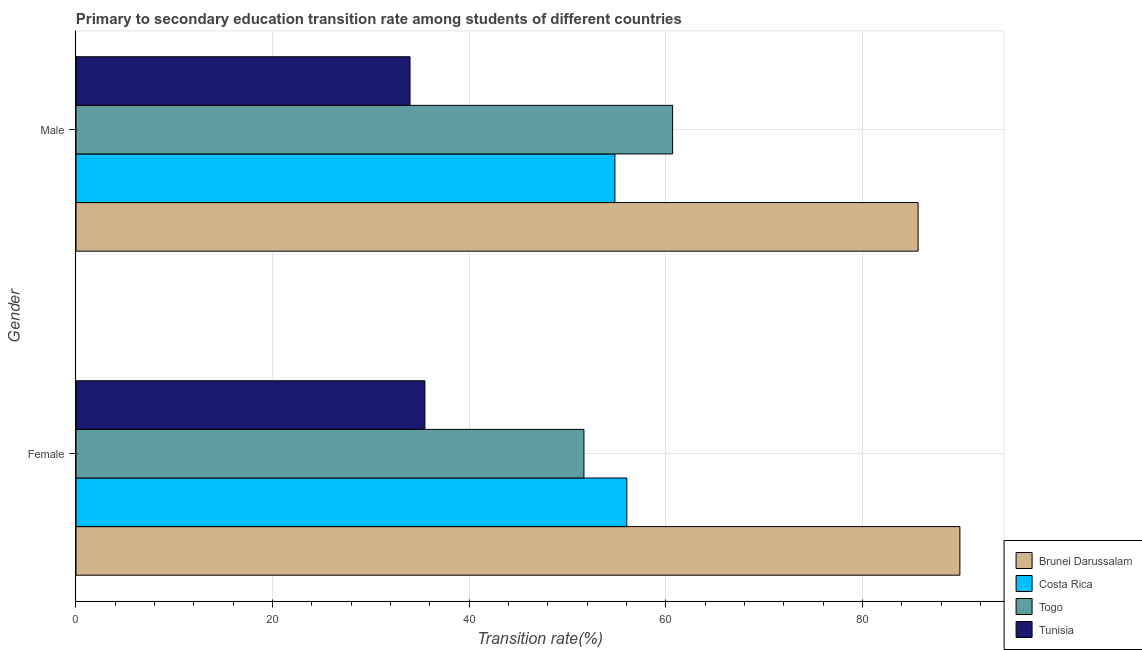What is the label of the 1st group of bars from the top?
Ensure brevity in your answer.  Male. What is the transition rate among female students in Tunisia?
Provide a succinct answer. 35.49. Across all countries, what is the maximum transition rate among male students?
Provide a short and direct response. 85.65. Across all countries, what is the minimum transition rate among male students?
Keep it short and to the point. 33.98. In which country was the transition rate among male students maximum?
Provide a succinct answer. Brunei Darussalam. In which country was the transition rate among male students minimum?
Keep it short and to the point. Tunisia. What is the total transition rate among female students in the graph?
Offer a terse response. 233.09. What is the difference between the transition rate among male students in Togo and that in Brunei Darussalam?
Offer a terse response. -24.97. What is the difference between the transition rate among female students in Tunisia and the transition rate among male students in Costa Rica?
Keep it short and to the point. -19.32. What is the average transition rate among male students per country?
Give a very brief answer. 58.78. What is the difference between the transition rate among male students and transition rate among female students in Costa Rica?
Your answer should be very brief. -1.21. In how many countries, is the transition rate among female students greater than 24 %?
Your answer should be very brief. 4. What is the ratio of the transition rate among female students in Togo to that in Tunisia?
Ensure brevity in your answer.  1.46. What does the 2nd bar from the top in Male represents?
Keep it short and to the point. Togo. What does the 3rd bar from the bottom in Female represents?
Keep it short and to the point. Togo. How many bars are there?
Make the answer very short. 8. How many countries are there in the graph?
Your answer should be compact. 4. What is the difference between two consecutive major ticks on the X-axis?
Provide a short and direct response. 20. Does the graph contain any zero values?
Make the answer very short. No. Does the graph contain grids?
Make the answer very short. Yes. How many legend labels are there?
Provide a short and direct response. 4. How are the legend labels stacked?
Give a very brief answer. Vertical. What is the title of the graph?
Your answer should be compact. Primary to secondary education transition rate among students of different countries. Does "Fiji" appear as one of the legend labels in the graph?
Your response must be concise. No. What is the label or title of the X-axis?
Make the answer very short. Transition rate(%). What is the Transition rate(%) of Brunei Darussalam in Female?
Ensure brevity in your answer.  89.9. What is the Transition rate(%) in Costa Rica in Female?
Offer a terse response. 56.03. What is the Transition rate(%) in Togo in Female?
Offer a terse response. 51.67. What is the Transition rate(%) in Tunisia in Female?
Make the answer very short. 35.49. What is the Transition rate(%) of Brunei Darussalam in Male?
Give a very brief answer. 85.65. What is the Transition rate(%) of Costa Rica in Male?
Your answer should be very brief. 54.82. What is the Transition rate(%) of Togo in Male?
Keep it short and to the point. 60.68. What is the Transition rate(%) of Tunisia in Male?
Your answer should be compact. 33.98. Across all Gender, what is the maximum Transition rate(%) of Brunei Darussalam?
Keep it short and to the point. 89.9. Across all Gender, what is the maximum Transition rate(%) in Costa Rica?
Give a very brief answer. 56.03. Across all Gender, what is the maximum Transition rate(%) of Togo?
Ensure brevity in your answer.  60.68. Across all Gender, what is the maximum Transition rate(%) in Tunisia?
Offer a terse response. 35.49. Across all Gender, what is the minimum Transition rate(%) in Brunei Darussalam?
Your answer should be compact. 85.65. Across all Gender, what is the minimum Transition rate(%) of Costa Rica?
Provide a short and direct response. 54.82. Across all Gender, what is the minimum Transition rate(%) of Togo?
Offer a very short reply. 51.67. Across all Gender, what is the minimum Transition rate(%) of Tunisia?
Give a very brief answer. 33.98. What is the total Transition rate(%) in Brunei Darussalam in the graph?
Offer a very short reply. 175.56. What is the total Transition rate(%) of Costa Rica in the graph?
Ensure brevity in your answer.  110.84. What is the total Transition rate(%) in Togo in the graph?
Give a very brief answer. 112.35. What is the total Transition rate(%) of Tunisia in the graph?
Provide a succinct answer. 69.47. What is the difference between the Transition rate(%) in Brunei Darussalam in Female and that in Male?
Keep it short and to the point. 4.25. What is the difference between the Transition rate(%) of Costa Rica in Female and that in Male?
Provide a short and direct response. 1.21. What is the difference between the Transition rate(%) of Togo in Female and that in Male?
Ensure brevity in your answer.  -9.02. What is the difference between the Transition rate(%) in Tunisia in Female and that in Male?
Ensure brevity in your answer.  1.52. What is the difference between the Transition rate(%) of Brunei Darussalam in Female and the Transition rate(%) of Costa Rica in Male?
Keep it short and to the point. 35.09. What is the difference between the Transition rate(%) in Brunei Darussalam in Female and the Transition rate(%) in Togo in Male?
Ensure brevity in your answer.  29.22. What is the difference between the Transition rate(%) in Brunei Darussalam in Female and the Transition rate(%) in Tunisia in Male?
Offer a terse response. 55.93. What is the difference between the Transition rate(%) of Costa Rica in Female and the Transition rate(%) of Togo in Male?
Provide a short and direct response. -4.66. What is the difference between the Transition rate(%) of Costa Rica in Female and the Transition rate(%) of Tunisia in Male?
Keep it short and to the point. 22.05. What is the difference between the Transition rate(%) in Togo in Female and the Transition rate(%) in Tunisia in Male?
Provide a short and direct response. 17.69. What is the average Transition rate(%) of Brunei Darussalam per Gender?
Your response must be concise. 87.78. What is the average Transition rate(%) in Costa Rica per Gender?
Give a very brief answer. 55.42. What is the average Transition rate(%) in Togo per Gender?
Make the answer very short. 56.17. What is the average Transition rate(%) in Tunisia per Gender?
Keep it short and to the point. 34.73. What is the difference between the Transition rate(%) in Brunei Darussalam and Transition rate(%) in Costa Rica in Female?
Your answer should be compact. 33.88. What is the difference between the Transition rate(%) in Brunei Darussalam and Transition rate(%) in Togo in Female?
Give a very brief answer. 38.24. What is the difference between the Transition rate(%) of Brunei Darussalam and Transition rate(%) of Tunisia in Female?
Offer a terse response. 54.41. What is the difference between the Transition rate(%) in Costa Rica and Transition rate(%) in Togo in Female?
Ensure brevity in your answer.  4.36. What is the difference between the Transition rate(%) of Costa Rica and Transition rate(%) of Tunisia in Female?
Offer a very short reply. 20.54. What is the difference between the Transition rate(%) in Togo and Transition rate(%) in Tunisia in Female?
Offer a terse response. 16.17. What is the difference between the Transition rate(%) of Brunei Darussalam and Transition rate(%) of Costa Rica in Male?
Provide a succinct answer. 30.84. What is the difference between the Transition rate(%) in Brunei Darussalam and Transition rate(%) in Togo in Male?
Ensure brevity in your answer.  24.97. What is the difference between the Transition rate(%) of Brunei Darussalam and Transition rate(%) of Tunisia in Male?
Offer a very short reply. 51.68. What is the difference between the Transition rate(%) in Costa Rica and Transition rate(%) in Togo in Male?
Give a very brief answer. -5.87. What is the difference between the Transition rate(%) of Costa Rica and Transition rate(%) of Tunisia in Male?
Your answer should be very brief. 20.84. What is the difference between the Transition rate(%) in Togo and Transition rate(%) in Tunisia in Male?
Offer a terse response. 26.71. What is the ratio of the Transition rate(%) of Brunei Darussalam in Female to that in Male?
Offer a terse response. 1.05. What is the ratio of the Transition rate(%) of Costa Rica in Female to that in Male?
Make the answer very short. 1.02. What is the ratio of the Transition rate(%) in Togo in Female to that in Male?
Offer a terse response. 0.85. What is the ratio of the Transition rate(%) of Tunisia in Female to that in Male?
Keep it short and to the point. 1.04. What is the difference between the highest and the second highest Transition rate(%) in Brunei Darussalam?
Provide a succinct answer. 4.25. What is the difference between the highest and the second highest Transition rate(%) of Costa Rica?
Your answer should be compact. 1.21. What is the difference between the highest and the second highest Transition rate(%) in Togo?
Offer a terse response. 9.02. What is the difference between the highest and the second highest Transition rate(%) of Tunisia?
Your answer should be very brief. 1.52. What is the difference between the highest and the lowest Transition rate(%) in Brunei Darussalam?
Offer a terse response. 4.25. What is the difference between the highest and the lowest Transition rate(%) in Costa Rica?
Your response must be concise. 1.21. What is the difference between the highest and the lowest Transition rate(%) in Togo?
Your answer should be compact. 9.02. What is the difference between the highest and the lowest Transition rate(%) of Tunisia?
Make the answer very short. 1.52. 